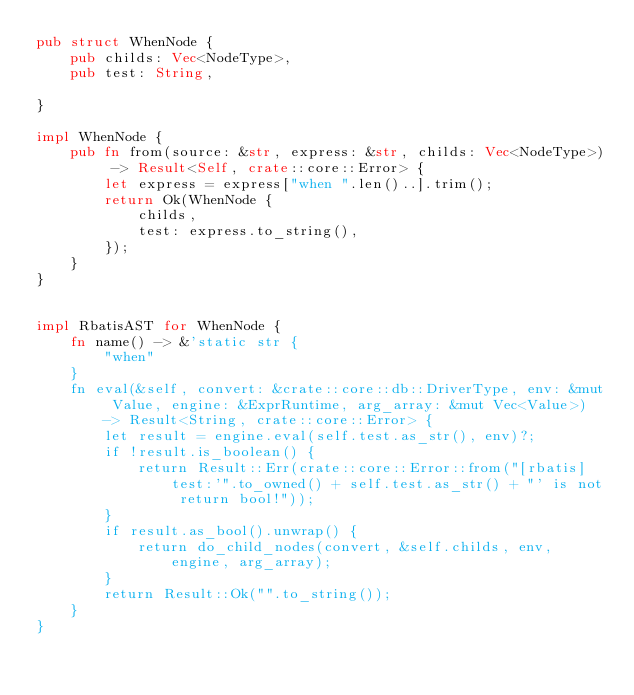Convert code to text. <code><loc_0><loc_0><loc_500><loc_500><_Rust_>pub struct WhenNode {
    pub childs: Vec<NodeType>,
    pub test: String,

}

impl WhenNode {
    pub fn from(source: &str, express: &str, childs: Vec<NodeType>) -> Result<Self, crate::core::Error> {
        let express = express["when ".len()..].trim();
        return Ok(WhenNode {
            childs,
            test: express.to_string(),
        });
    }
}


impl RbatisAST for WhenNode {
    fn name() -> &'static str {
        "when"
    }
    fn eval(&self, convert: &crate::core::db::DriverType, env: &mut Value, engine: &ExprRuntime, arg_array: &mut Vec<Value>) -> Result<String, crate::core::Error> {
        let result = engine.eval(self.test.as_str(), env)?;
        if !result.is_boolean() {
            return Result::Err(crate::core::Error::from("[rbatis] test:'".to_owned() + self.test.as_str() + "' is not return bool!"));
        }
        if result.as_bool().unwrap() {
            return do_child_nodes(convert, &self.childs, env, engine, arg_array);
        }
        return Result::Ok("".to_string());
    }
}</code> 